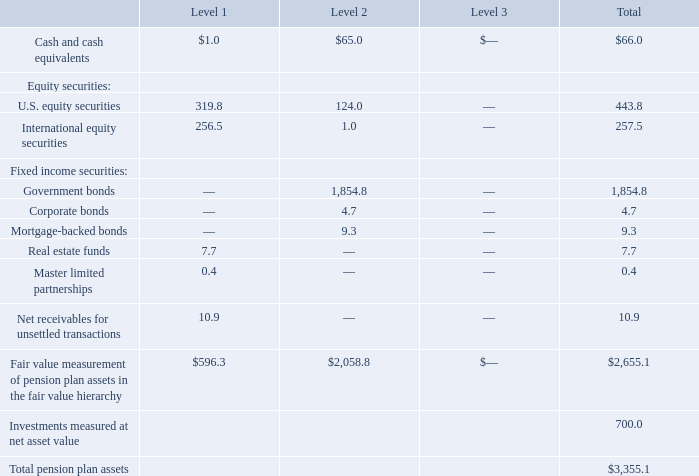The fair value of plan assets, summarized by level within the fair value hierarchy described in Note 20, as of May 27, 2018, was as follows:
Level 1 assets are valued based on quoted prices in active markets for identical securities. The majority of the Level 1 assets listed above include the common stock of both U.S. and international companies, mutual funds, master limited partnership units, and real estate investment trusts, all of which are actively traded and priced in the market.
Level 2 assets are valued based on other significant observable inputs including quoted prices for similar securities, yield curves, indices, etc. Level 2 assets consist primarily of individual fixed income securities where values are based on quoted prices of similar securities and observable market data.
Level 3 assets consist of investments where active market pricing is not readily available and, as such, fair value is estimated using significant unobservable inputs.
Certain assets that are measured at fair value using the NAV (net asset value) per share (or its equivalent) practical expedient have not been classified in the fair value hierarchy. Such investments are generally considered long-term in nature with varying redemption availability. For certain of these investments, with a fair value of approximately $51.0 million as of May 26, 2019, the asset managers have the ability to impose customary redemption gates which may further restrict or limit the redemption of invested funds therein. As of May 26, 2019, funds with a fair value of $4.2 million have imposed such gates.
As of May 26, 2019, we have unfunded commitments for additional investments of $48.3 million in private equity funds and $17.0 million in natural resources funds. We expect unfunded commitments to be funded from plan assets rather than the general assets of the Company.
Notes to Consolidated Financial Statements - (Continued) Fiscal Years Ended May 26, 2019, May 27, 2018, and May 28, 2017 (columnar dollars in millions except per share amounts)
What are Level 2 assets primarily consist of? Individual fixed income securities where values are based on quoted prices of similar securities and observable market data. What are Level 3 assets consist of? Investments where active market pricing is not readily available and, as such, fair value is estimated using significant unobservable inputs. What are the fair values of Level 2 government bonds and corporate bonds, respectively?
Answer scale should be: million. 1,854.8, 4.7. What is the proportion of equity securities over the total fair value measurement of pension plan assets of Level 1 assets? (319.8+256.5)/596.3 
Answer: 0.97. Which fixed income securities have the highest fair value? 1,854.8>9.3>4.7
Answer: government bonds. What is the proportion (in percentage) of real estate funds and master limited partnerships over the total pension plan assets?
Answer scale should be: percent. (7.7+0.4)/3,355.1 
Answer: 0.24. 